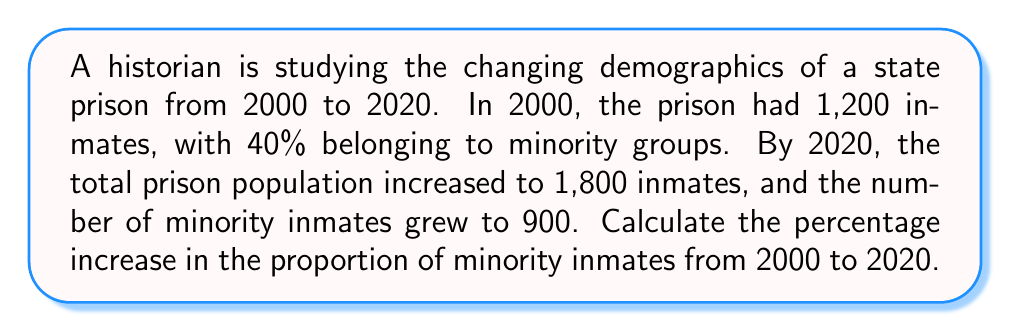Can you answer this question? To solve this problem, we'll follow these steps:

1. Calculate the number of minority inmates in 2000:
   $$ 40\% \text{ of } 1,200 = 0.40 \times 1,200 = 480 \text{ minority inmates} $$

2. Calculate the percentage of minority inmates in 2020:
   $$ \frac{\text{Minority inmates}}{\text{Total inmates}} \times 100\% = \frac{900}{1,800} \times 100\% = 50\% $$

3. Calculate the increase in percentage points:
   $$ 50\% - 40\% = 10 \text{ percentage points} $$

4. Calculate the percentage increase:
   $$ \text{Percentage increase} = \frac{\text{Increase}}{\text{Original}} \times 100\% $$
   $$ = \frac{10}{40} \times 100\% = 0.25 \times 100\% = 25\% $$

Therefore, the percentage increase in the proportion of minority inmates from 2000 to 2020 is 25%.
Answer: 25% 